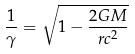Convert formula to latex. <formula><loc_0><loc_0><loc_500><loc_500>\frac { 1 } { \gamma } = \sqrt { 1 - \frac { 2 G M } { r c ^ { 2 } } }</formula> 